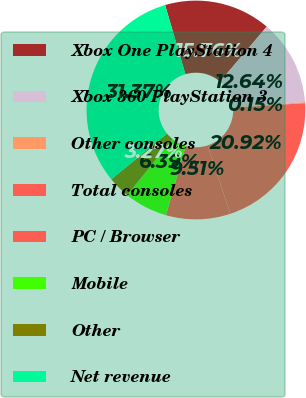<chart> <loc_0><loc_0><loc_500><loc_500><pie_chart><fcel>Xbox One PlayStation 4<fcel>Xbox 360 PlayStation 3<fcel>Other consoles<fcel>Total consoles<fcel>PC / Browser<fcel>Mobile<fcel>Other<fcel>Net revenue<nl><fcel>15.76%<fcel>12.64%<fcel>0.15%<fcel>20.92%<fcel>9.51%<fcel>6.39%<fcel>3.27%<fcel>31.37%<nl></chart> 